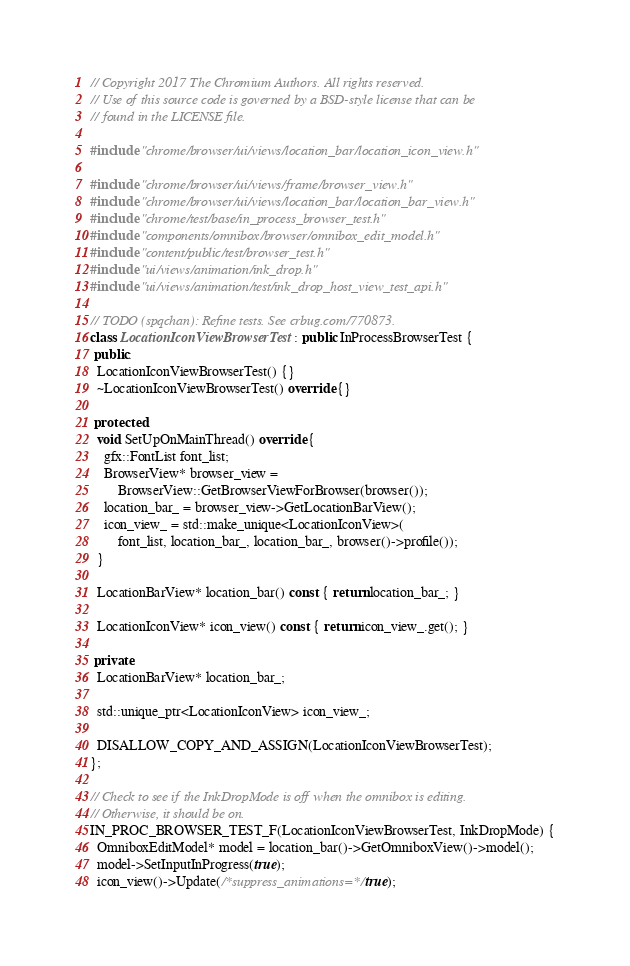Convert code to text. <code><loc_0><loc_0><loc_500><loc_500><_C++_>// Copyright 2017 The Chromium Authors. All rights reserved.
// Use of this source code is governed by a BSD-style license that can be
// found in the LICENSE file.

#include "chrome/browser/ui/views/location_bar/location_icon_view.h"

#include "chrome/browser/ui/views/frame/browser_view.h"
#include "chrome/browser/ui/views/location_bar/location_bar_view.h"
#include "chrome/test/base/in_process_browser_test.h"
#include "components/omnibox/browser/omnibox_edit_model.h"
#include "content/public/test/browser_test.h"
#include "ui/views/animation/ink_drop.h"
#include "ui/views/animation/test/ink_drop_host_view_test_api.h"

// TODO (spqchan): Refine tests. See crbug.com/770873.
class LocationIconViewBrowserTest : public InProcessBrowserTest {
 public:
  LocationIconViewBrowserTest() {}
  ~LocationIconViewBrowserTest() override {}

 protected:
  void SetUpOnMainThread() override {
    gfx::FontList font_list;
    BrowserView* browser_view =
        BrowserView::GetBrowserViewForBrowser(browser());
    location_bar_ = browser_view->GetLocationBarView();
    icon_view_ = std::make_unique<LocationIconView>(
        font_list, location_bar_, location_bar_, browser()->profile());
  }

  LocationBarView* location_bar() const { return location_bar_; }

  LocationIconView* icon_view() const { return icon_view_.get(); }

 private:
  LocationBarView* location_bar_;

  std::unique_ptr<LocationIconView> icon_view_;

  DISALLOW_COPY_AND_ASSIGN(LocationIconViewBrowserTest);
};

// Check to see if the InkDropMode is off when the omnibox is editing.
// Otherwise, it should be on.
IN_PROC_BROWSER_TEST_F(LocationIconViewBrowserTest, InkDropMode) {
  OmniboxEditModel* model = location_bar()->GetOmniboxView()->model();
  model->SetInputInProgress(true);
  icon_view()->Update(/*suppress_animations=*/true);
</code> 